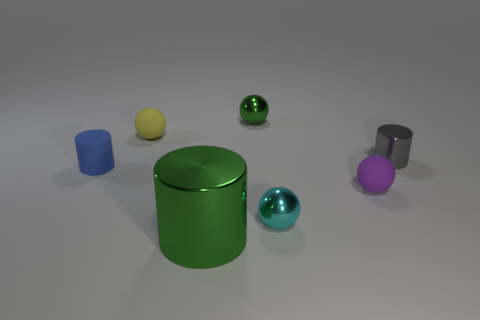Subtract all metal cylinders. How many cylinders are left? 1 Subtract all yellow balls. How many balls are left? 3 Add 2 small yellow metallic cylinders. How many objects exist? 9 Subtract all purple cylinders. Subtract all purple blocks. How many cylinders are left? 3 Subtract all balls. How many objects are left? 3 Add 4 tiny blue matte cylinders. How many tiny blue matte cylinders are left? 5 Add 6 green things. How many green things exist? 8 Subtract 0 red balls. How many objects are left? 7 Subtract all tiny purple rubber balls. Subtract all balls. How many objects are left? 2 